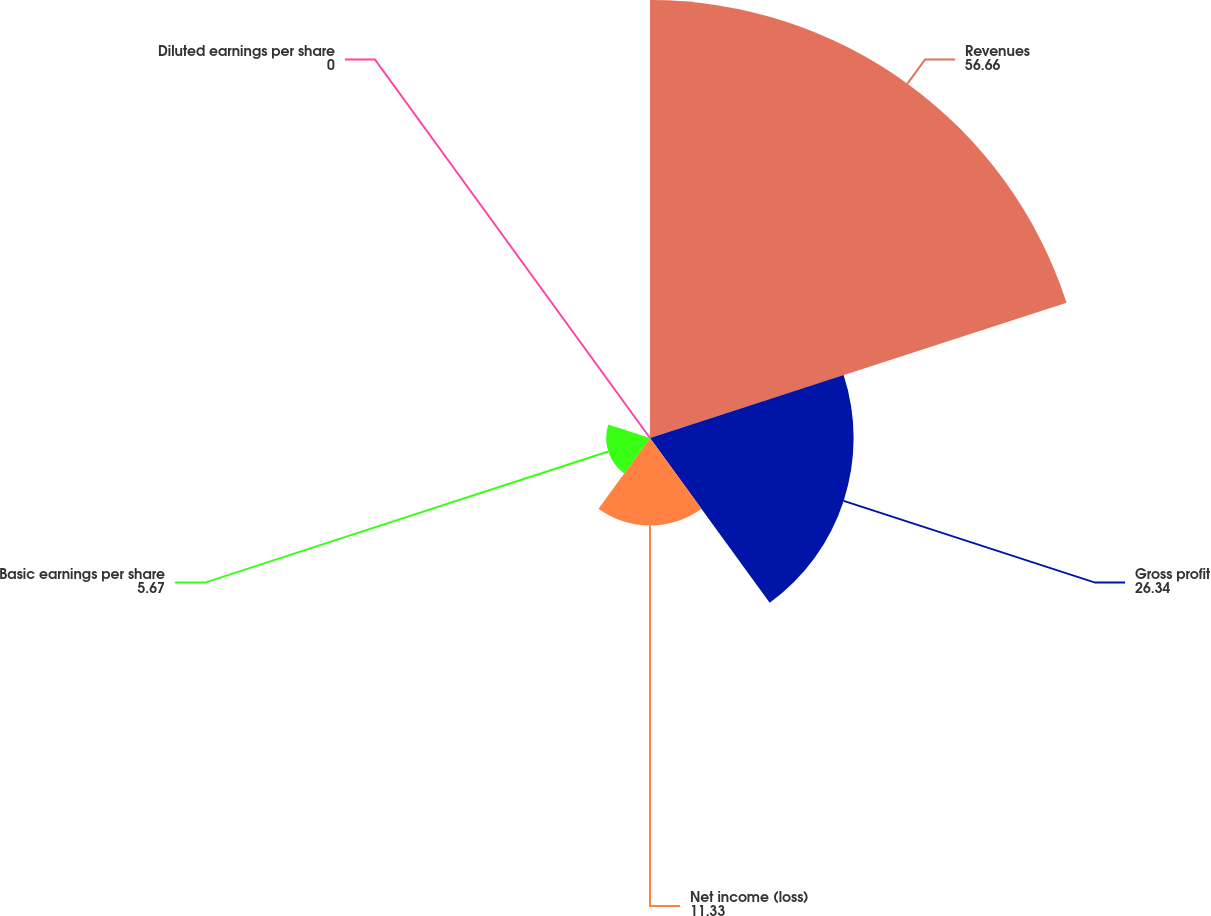Convert chart. <chart><loc_0><loc_0><loc_500><loc_500><pie_chart><fcel>Revenues<fcel>Gross profit<fcel>Net income (loss)<fcel>Basic earnings per share<fcel>Diluted earnings per share<nl><fcel>56.66%<fcel>26.34%<fcel>11.33%<fcel>5.67%<fcel>0.0%<nl></chart> 